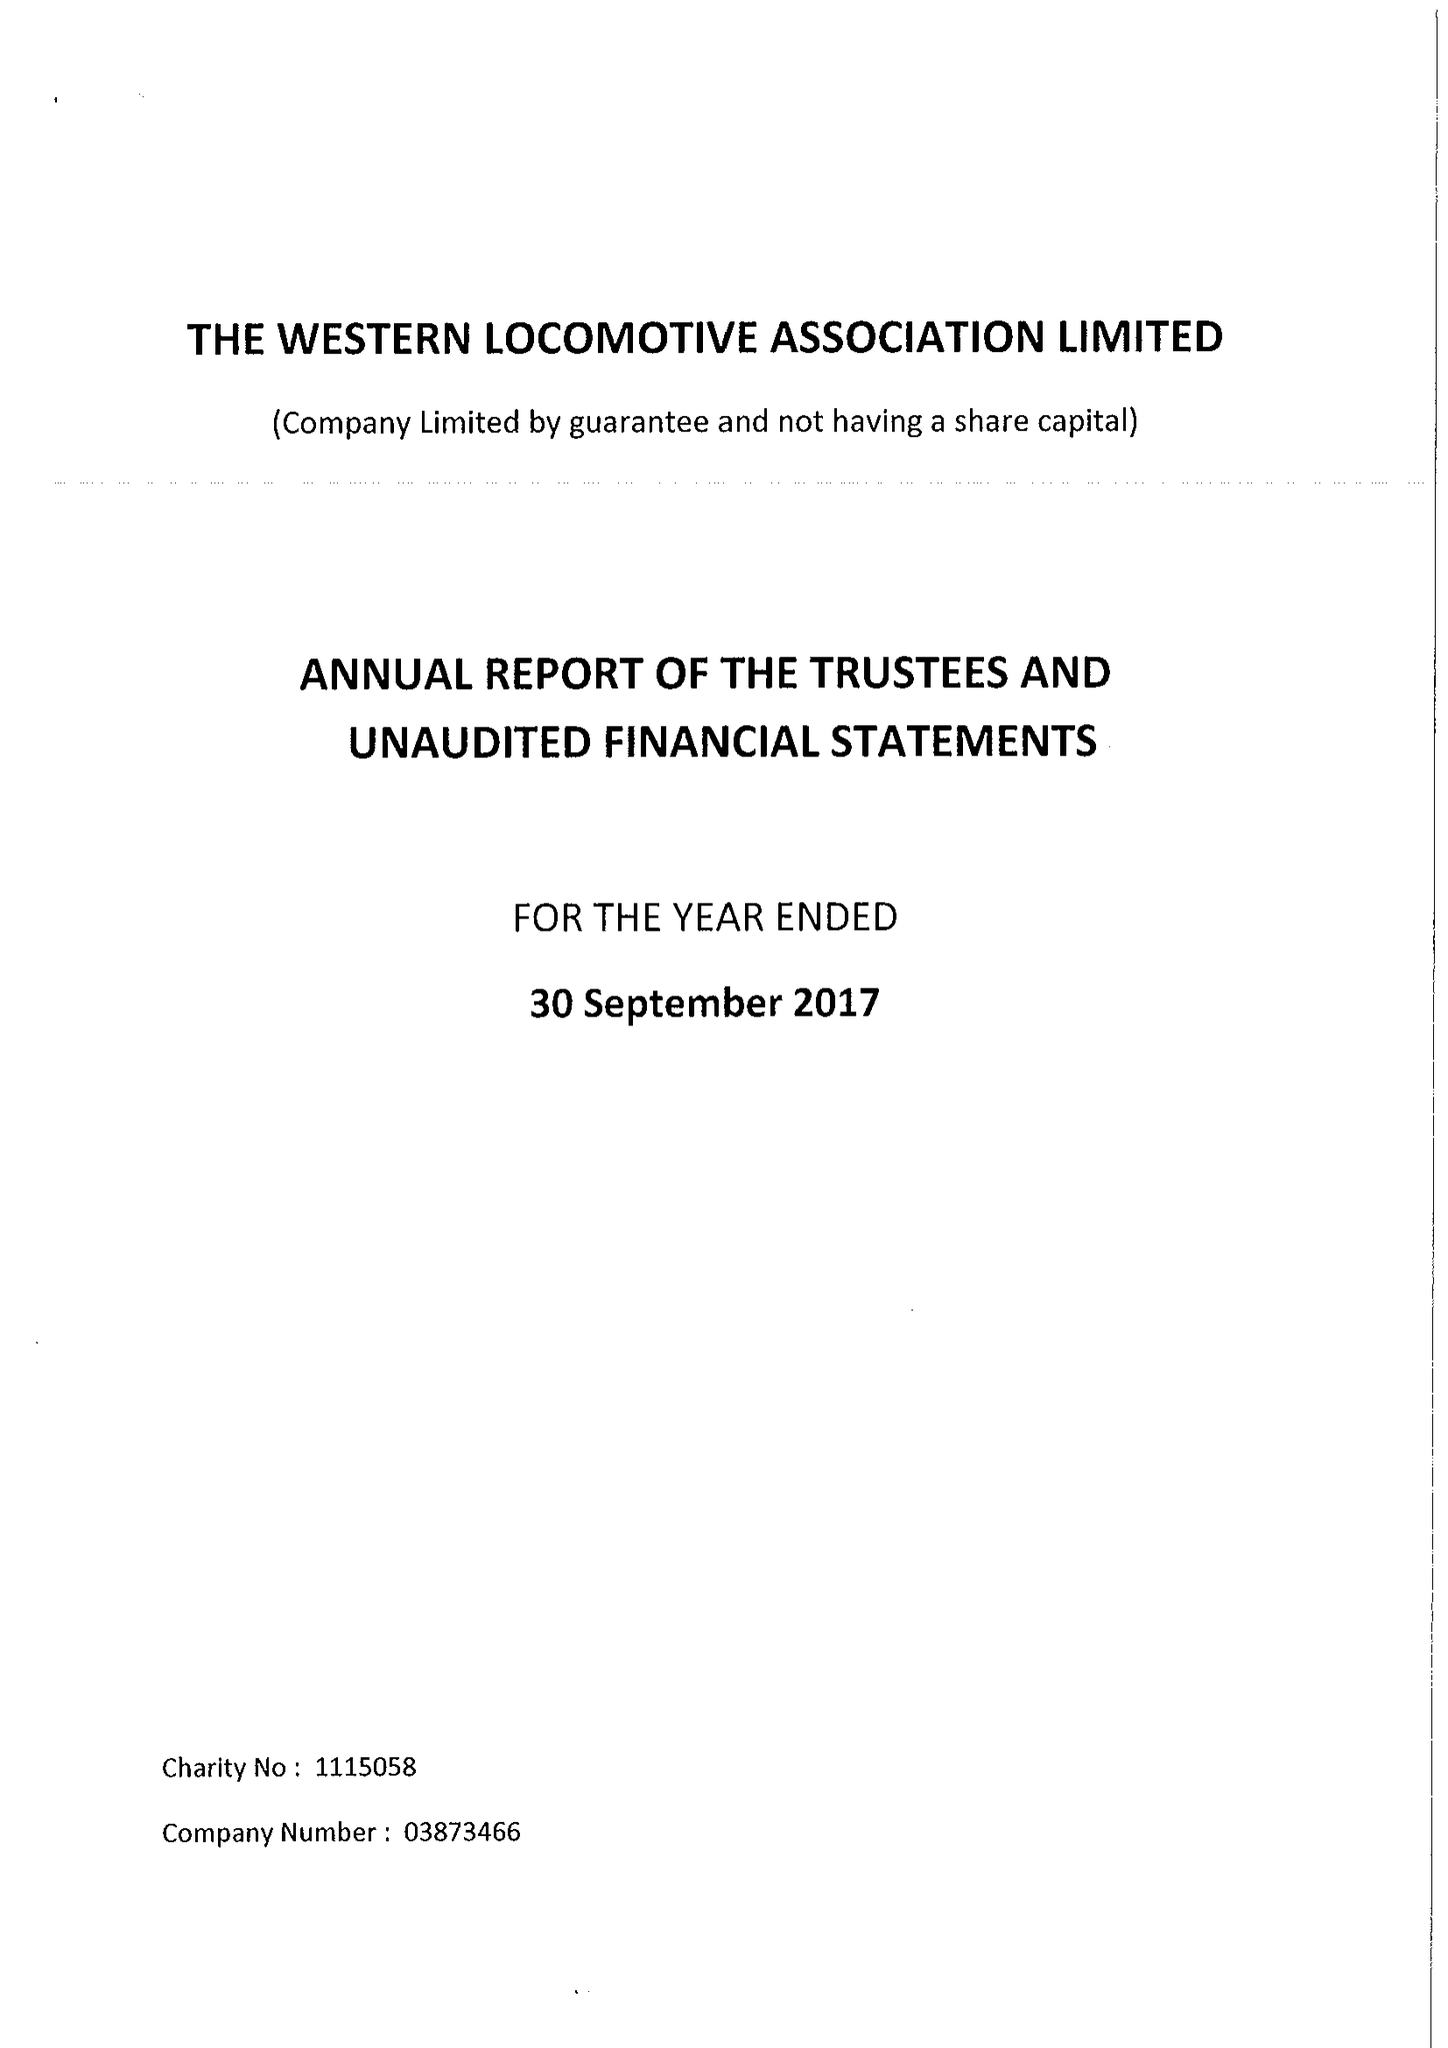What is the value for the charity_name?
Answer the question using a single word or phrase. Western Locomotive Association Ltd. 